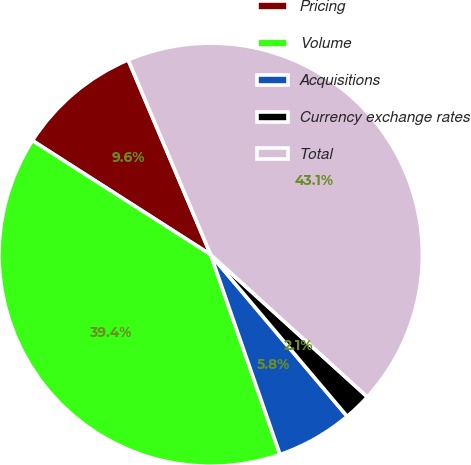Convert chart. <chart><loc_0><loc_0><loc_500><loc_500><pie_chart><fcel>Pricing<fcel>Volume<fcel>Acquisitions<fcel>Currency exchange rates<fcel>Total<nl><fcel>9.56%<fcel>39.38%<fcel>5.84%<fcel>2.11%<fcel>43.11%<nl></chart> 